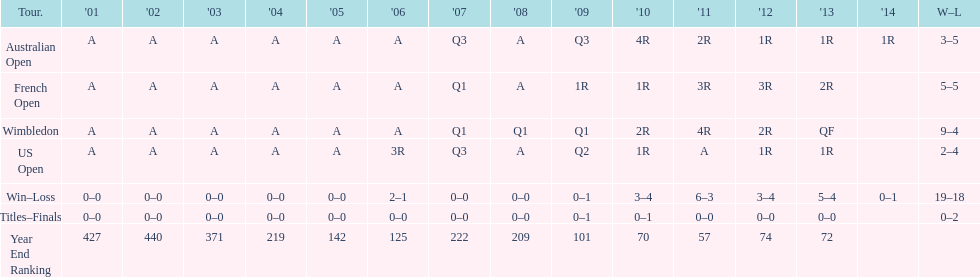I'm looking to parse the entire table for insights. Could you assist me with that? {'header': ['Tour.', "'01", "'02", "'03", "'04", "'05", "'06", "'07", "'08", "'09", "'10", "'11", "'12", "'13", "'14", 'W–L'], 'rows': [['Australian Open', 'A', 'A', 'A', 'A', 'A', 'A', 'Q3', 'A', 'Q3', '4R', '2R', '1R', '1R', '1R', '3–5'], ['French Open', 'A', 'A', 'A', 'A', 'A', 'A', 'Q1', 'A', '1R', '1R', '3R', '3R', '2R', '', '5–5'], ['Wimbledon', 'A', 'A', 'A', 'A', 'A', 'A', 'Q1', 'Q1', 'Q1', '2R', '4R', '2R', 'QF', '', '9–4'], ['US Open', 'A', 'A', 'A', 'A', 'A', '3R', 'Q3', 'A', 'Q2', '1R', 'A', '1R', '1R', '', '2–4'], ['Win–Loss', '0–0', '0–0', '0–0', '0–0', '0–0', '2–1', '0–0', '0–0', '0–1', '3–4', '6–3', '3–4', '5–4', '0–1', '19–18'], ['Titles–Finals', '0–0', '0–0', '0–0', '0–0', '0–0', '0–0', '0–0', '0–0', '0–1', '0–1', '0–0', '0–0', '0–0', '', '0–2'], ['Year End Ranking', '427', '440', '371', '219', '142', '125', '222', '209', '101', '70', '57', '74', '72', '', '']]} During which years was there just one loss? 2006, 2009, 2014. 